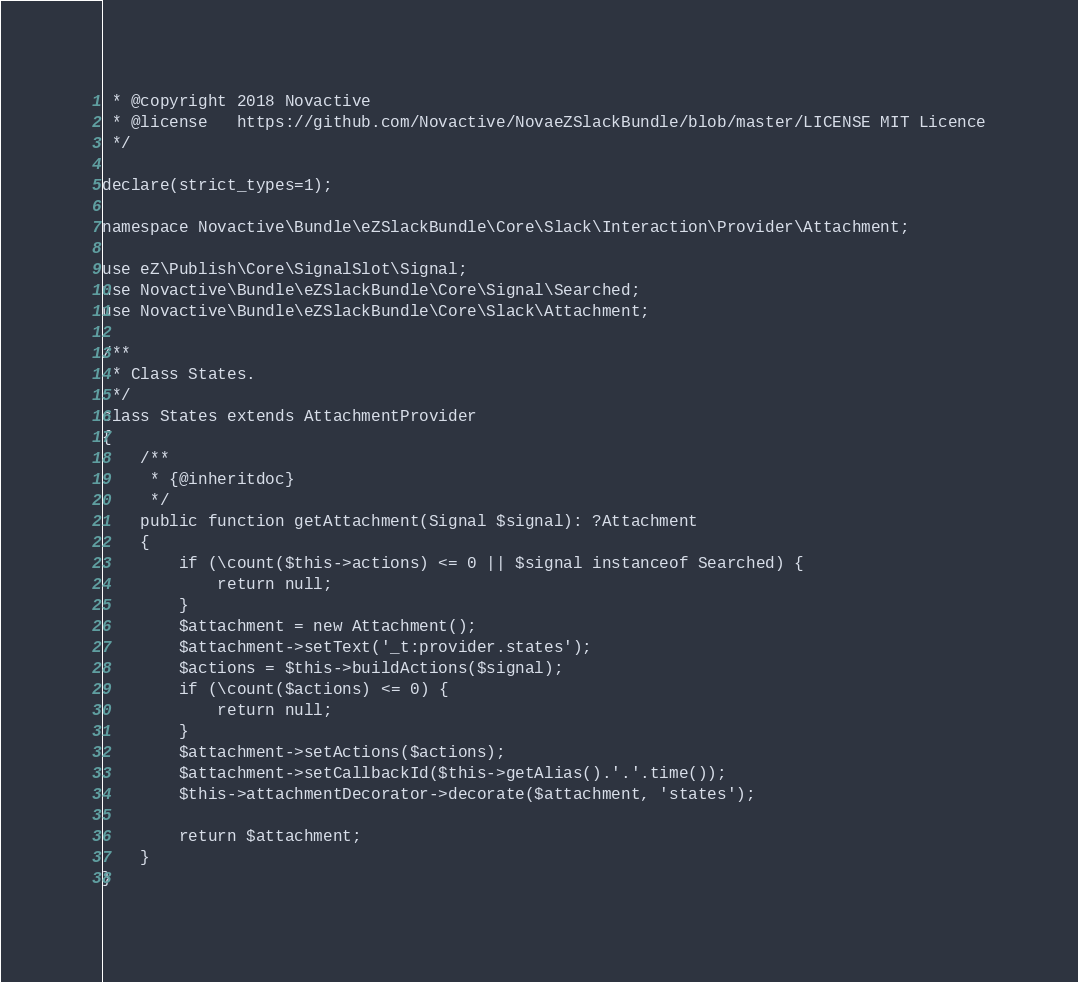<code> <loc_0><loc_0><loc_500><loc_500><_PHP_> * @copyright 2018 Novactive
 * @license   https://github.com/Novactive/NovaeZSlackBundle/blob/master/LICENSE MIT Licence
 */

declare(strict_types=1);

namespace Novactive\Bundle\eZSlackBundle\Core\Slack\Interaction\Provider\Attachment;

use eZ\Publish\Core\SignalSlot\Signal;
use Novactive\Bundle\eZSlackBundle\Core\Signal\Searched;
use Novactive\Bundle\eZSlackBundle\Core\Slack\Attachment;

/**
 * Class States.
 */
class States extends AttachmentProvider
{
    /**
     * {@inheritdoc}
     */
    public function getAttachment(Signal $signal): ?Attachment
    {
        if (\count($this->actions) <= 0 || $signal instanceof Searched) {
            return null;
        }
        $attachment = new Attachment();
        $attachment->setText('_t:provider.states');
        $actions = $this->buildActions($signal);
        if (\count($actions) <= 0) {
            return null;
        }
        $attachment->setActions($actions);
        $attachment->setCallbackId($this->getAlias().'.'.time());
        $this->attachmentDecorator->decorate($attachment, 'states');

        return $attachment;
    }
}
</code> 